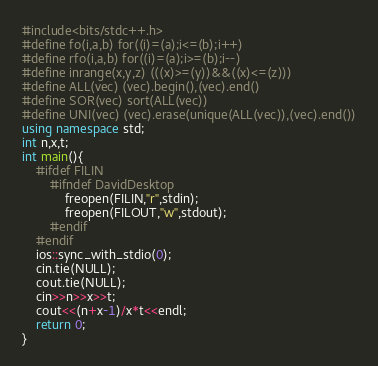<code> <loc_0><loc_0><loc_500><loc_500><_C++_>#include<bits/stdc++.h>
#define fo(i,a,b) for((i)=(a);i<=(b);i++)
#define rfo(i,a,b) for((i)=(a);i>=(b);i--)
#define inrange(x,y,z) (((x)>=(y))&&((x)<=(z)))
#define ALL(vec) (vec).begin(),(vec).end()
#define SOR(vec) sort(ALL(vec))
#define UNI(vec) (vec).erase(unique(ALL(vec)),(vec).end())
using namespace std;
int n,x,t;
int main(){
	#ifdef FILIN
		#ifndef DavidDesktop
			freopen(FILIN,"r",stdin);
			freopen(FILOUT,"w",stdout);
		#endif
	#endif
	ios::sync_with_stdio(0);
	cin.tie(NULL);
	cout.tie(NULL);
	cin>>n>>x>>t;
	cout<<(n+x-1)/x*t<<endl;
	return 0;
}
</code> 